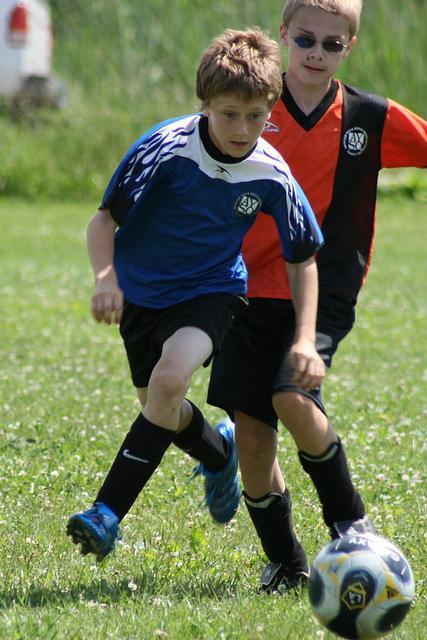How many people are there?
Give a very brief answer. 2. 